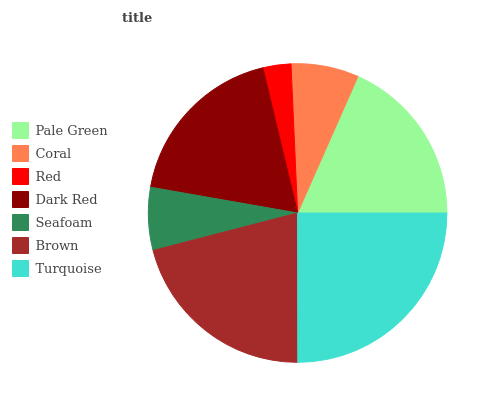Is Red the minimum?
Answer yes or no. Yes. Is Turquoise the maximum?
Answer yes or no. Yes. Is Coral the minimum?
Answer yes or no. No. Is Coral the maximum?
Answer yes or no. No. Is Pale Green greater than Coral?
Answer yes or no. Yes. Is Coral less than Pale Green?
Answer yes or no. Yes. Is Coral greater than Pale Green?
Answer yes or no. No. Is Pale Green less than Coral?
Answer yes or no. No. Is Pale Green the high median?
Answer yes or no. Yes. Is Pale Green the low median?
Answer yes or no. Yes. Is Dark Red the high median?
Answer yes or no. No. Is Turquoise the low median?
Answer yes or no. No. 